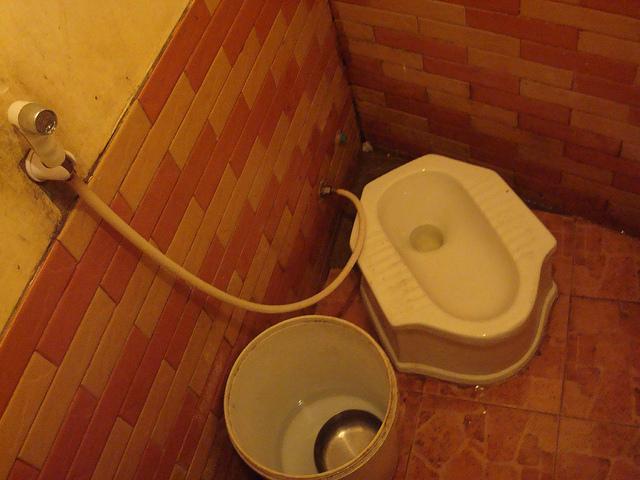Is the garbage can empty?
Write a very short answer. Yes. What is this?
Short answer required. Toilet. Are the tiles lined up on a diagonal?
Be succinct. Yes. 